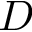<formula> <loc_0><loc_0><loc_500><loc_500>D</formula> 